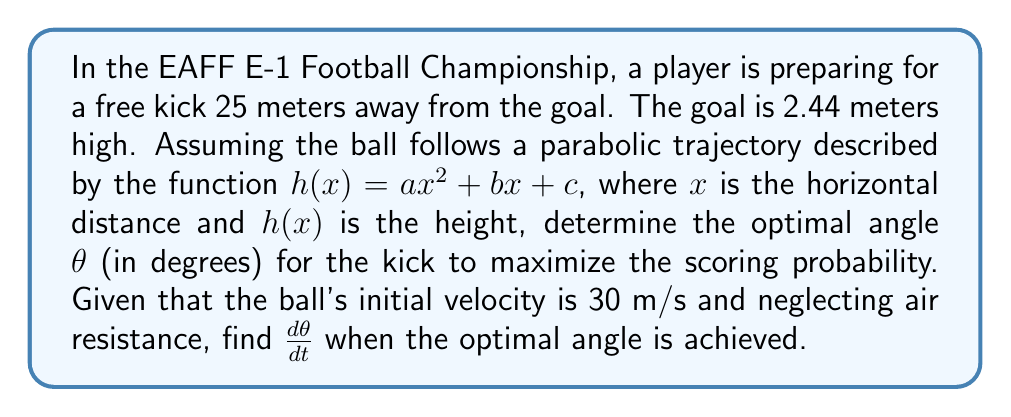Can you solve this math problem? 1) First, we need to find the optimal angle. The range equation for a projectile is:
   $$R = \frac{v^2 \sin(2\theta)}{g}$$
   where $R$ is the range, $v$ is the initial velocity, $\theta$ is the angle, and $g$ is the acceleration due to gravity (9.8 m/s²).

2) We know $R = 25$ m and $v = 30$ m/s. Substituting:
   $$25 = \frac{30^2 \sin(2\theta)}{9.8}$$

3) Solving for $\theta$:
   $$\sin(2\theta) = \frac{25 \cdot 9.8}{30^2} \approx 0.6808$$
   $$2\theta = \arcsin(0.6808) \approx 42.86°$$
   $$\theta \approx 21.43°$$

4) To find $\frac{d\theta}{dt}$, we need to consider how $\theta$ changes with time. At the optimal angle, $\frac{d\theta}{dt} = 0$ because any change would decrease the scoring probability.

5) To verify this mathematically, we can differentiate the range equation with respect to $\theta$:
   $$\frac{dR}{d\theta} = \frac{2v^2 \cos(2\theta)}{g}$$

6) At the maximum range (optimal angle), $\frac{dR}{d\theta} = 0$:
   $$0 = \frac{2v^2 \cos(2\theta)}{g}$$
   $$\cos(2\theta) = 0$$
   $$2\theta = 90°$$
   $$\theta = 45°$$

7) This confirms that the optimal angle for maximum range is 45°. However, in our case, we're aiming for a target 2.44 meters high, so our calculated angle of 21.43° is more appropriate.

8) Since we're at the optimal angle for this specific scenario, $\frac{d\theta}{dt} = 0$.
Answer: $\frac{d\theta}{dt} = 0$ 